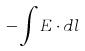<formula> <loc_0><loc_0><loc_500><loc_500>- \int E \cdot d l</formula> 